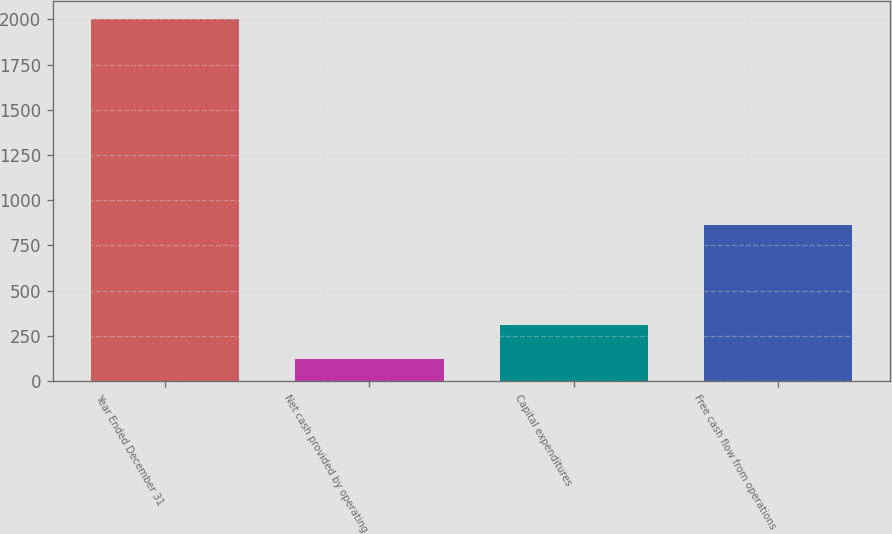Convert chart to OTSL. <chart><loc_0><loc_0><loc_500><loc_500><bar_chart><fcel>Year Ended December 31<fcel>Net cash provided by operating<fcel>Capital expenditures<fcel>Free cash flow from operations<nl><fcel>2002<fcel>122<fcel>310<fcel>860<nl></chart> 